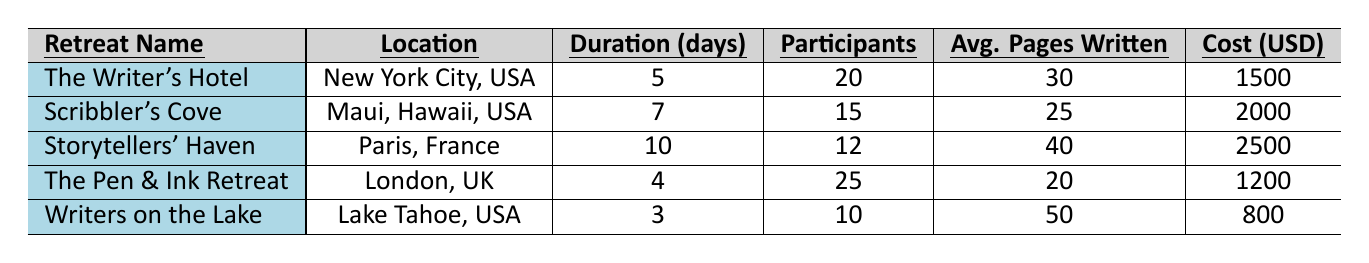What is the location of "Writers on the Lake"? The table lists "Writers on the Lake" under the location column, which shows it is located in Lake Tahoe, USA.
Answer: Lake Tahoe, USA How many participants are at "The Pen & Ink Retreat"? Referring to the table, "The Pen & Ink Retreat" has a participant count of 25 listed in the participants column.
Answer: 25 Which retreat has the highest average pages written? By comparing the average pages written data for each retreat from the table, "Writers on the Lake" has the highest average at 50 pages.
Answer: Writers on the Lake What is the cost per participant for "Scribbler's Cove"? The cost per participant for "Scribbler's Cove" is explicitly stated as 2000 USD in the cost column of the table.
Answer: 2000 USD Which retreat has the longest duration? Checking the duration column, "Storytellers' Haven" has the longest duration of 10 days compared to others.
Answer: 10 days Is there a networking opportunity at "The Pen & Ink Retreat"? The networking opportunities column indicates "The Pen & Ink Retreat" has a value of false, meaning there are no networking opportunities available.
Answer: No What is the total cost for all participants in "The Writer's Hotel"? The cost per participant is 1500 USD, and there are 20 participants, so total cost = 1500 * 20 = 30000 USD.
Answer: 30000 USD Which genre focus has the highest average pages written, and which retreat focuses on that genre? The average pages written for "Writers on the Lake" is the highest at 50 pages in the Children's Literature genre.
Answer: Children's Literature; Writers on the Lake How does the average pages written of "Writers on the Lake" compare to "Scribbler's Cove"? "Writers on the Lake" has 50 pages written on average, while "Scribbler's Cove" has 25 pages. Hence, the difference is 50 - 25 = 25 pages.
Answer: 25 pages What is the average cost per participant across all retreats? Sum the costs of all retreats (1500 + 2000 + 2500 + 1200 + 800) = 10000, then divide by the number of retreats (5), so the average cost is 10000 / 5 = 2000 USD.
Answer: 2000 USD 